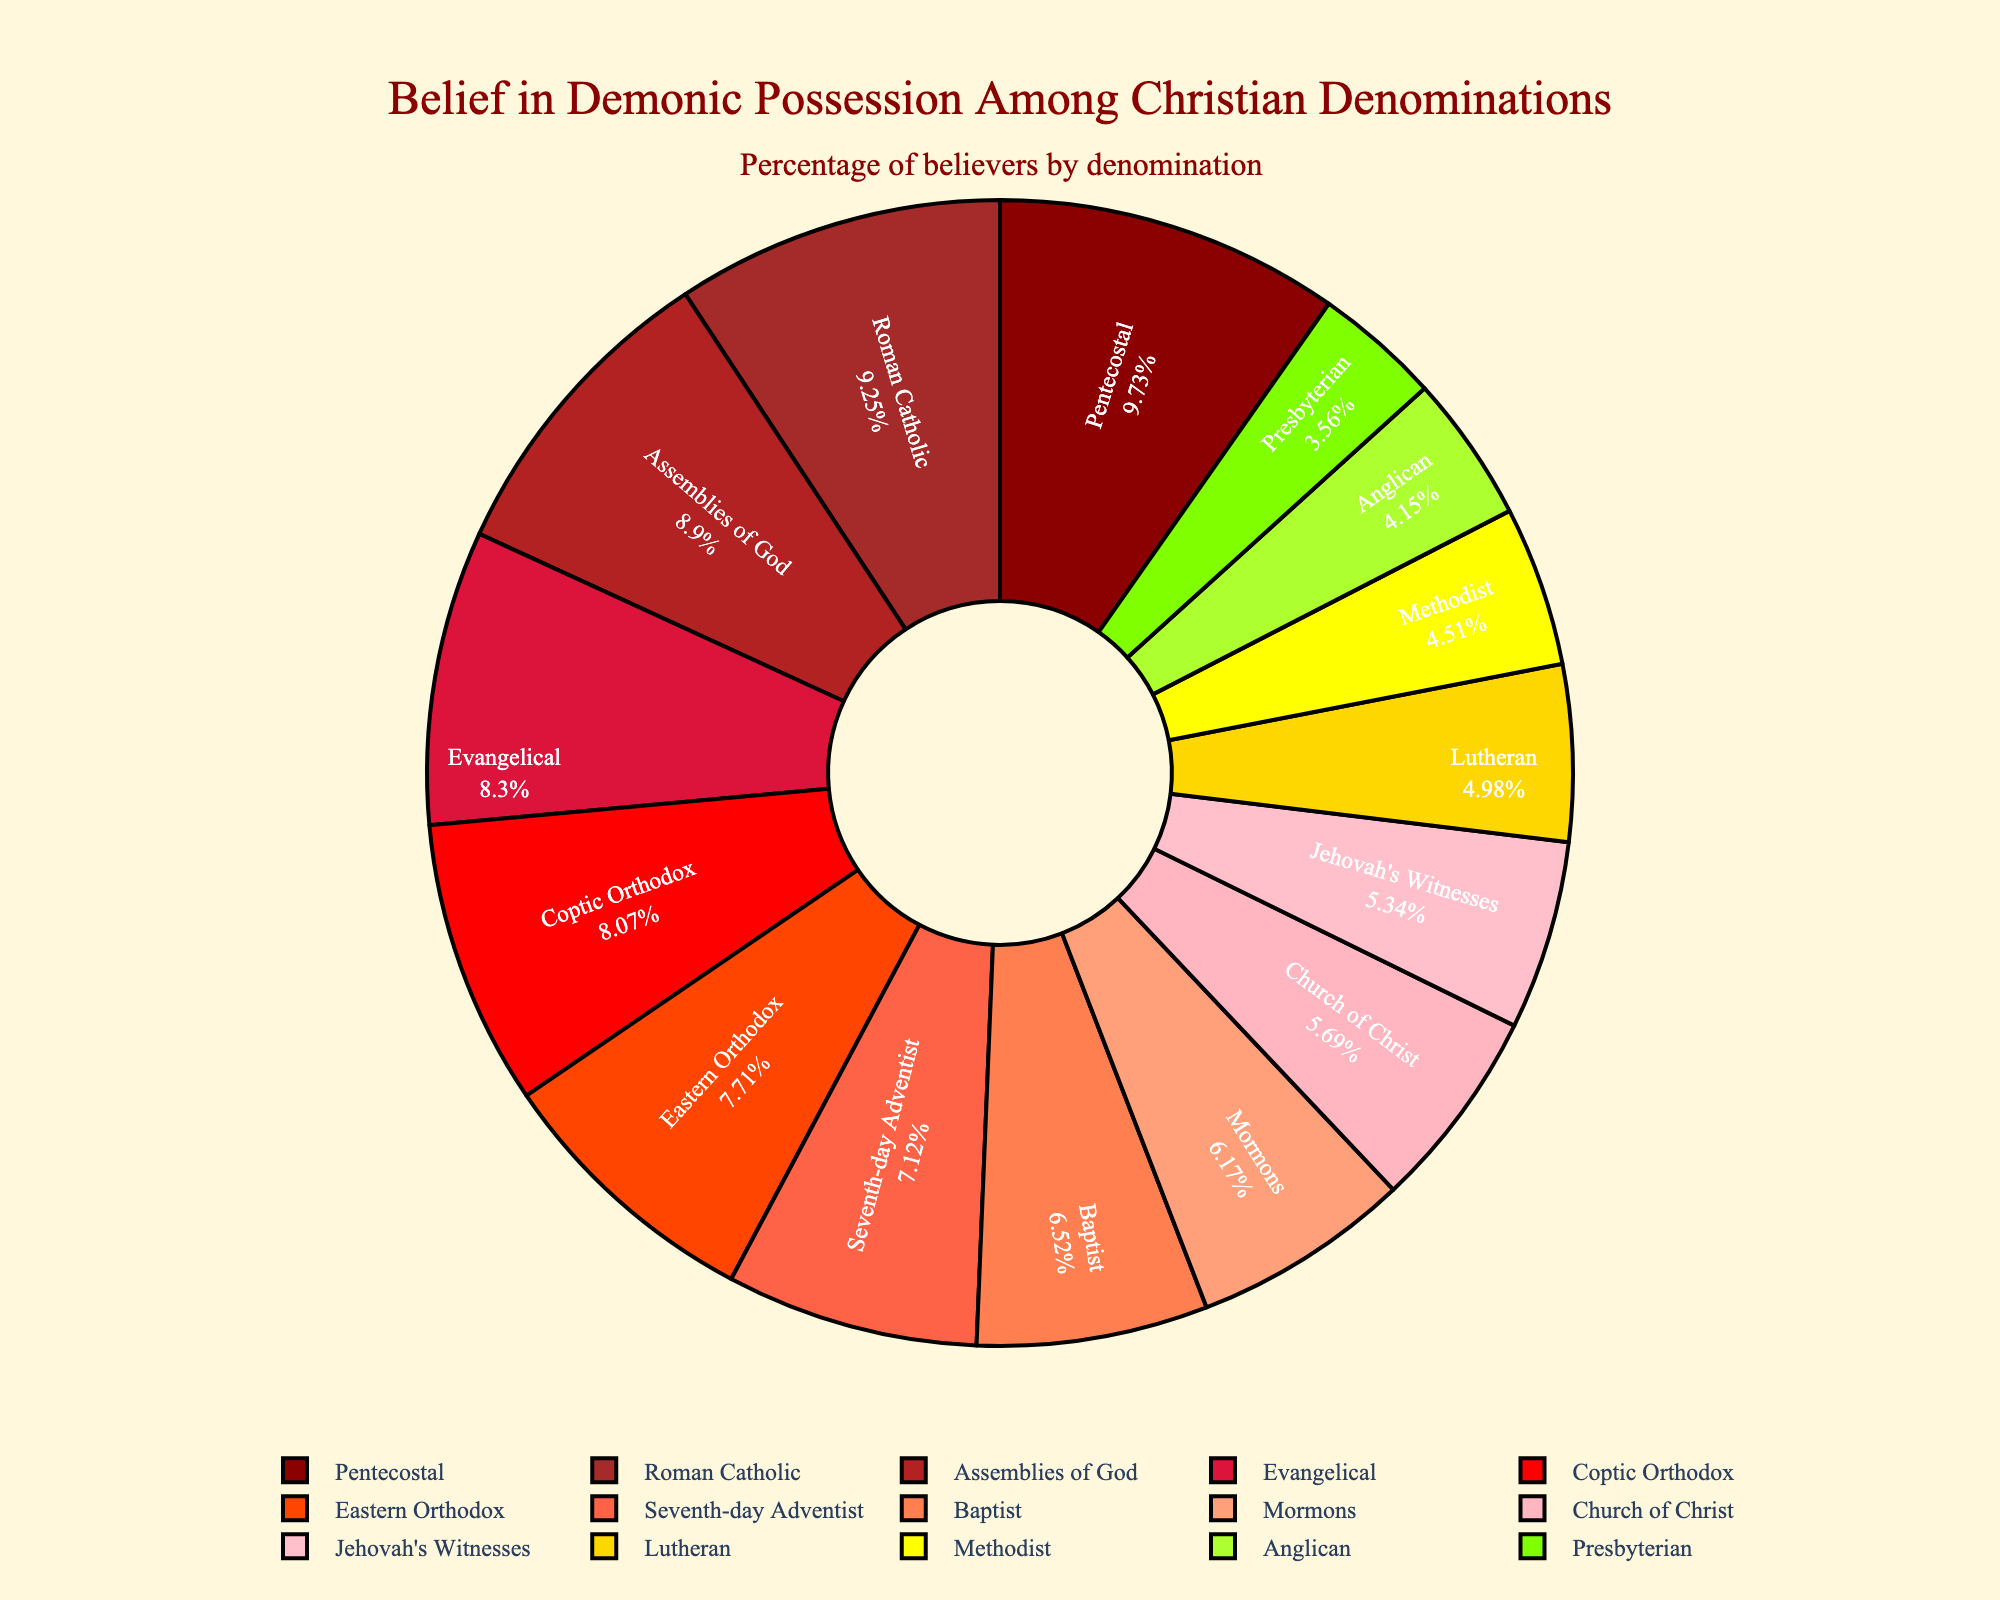Which denomination has the highest percentage belief in demonic possession? By examining the figure, the Pentecostal denomination has the largest segment, indicating the highest percentage belief at 82%.
Answer: Pentecostal Which denomination has the lowest percentage belief in demonic possession? The smallest segment of the pie chart corresponds to the Presbyterian denomination, with a percentage belief of 30%.
Answer: Presbyterian What is the difference in percentage belief between the Catholic and Anglican denominations? By referring to the figure, Roman Catholics have a belief percentage of 78%, and Anglicans have 35%. The difference is calculated as 78% - 35% = 43%.
Answer: 43% What is the combined percentage belief among the Assemblies of God and Baptist denominations? According to the figure, the Assemblies of God denomination has a 75% belief rate, while the Baptist denomination has 55%. Adding these together gives 75% + 55% = 130%.
Answer: 130% How does the belief in demonic possession in the Eastern Orthodox Church compare to that in the Jehovah's Witnesses? The figure shows Eastern Orthodox Christians at 65% and Jehovah's Witnesses at 45%. Eastern Orthodox are thus 20 percentage points higher in belief.
Answer: Eastern Orthodox are 20% higher Which denomination represented by a red segment has a belief percentage above 70%? The red segments represent high belief percentages. The Pentecostal (82%), Assemblies of God (75%), Roman Catholic (78%), and Eastern Orthodox (65%) denominations are candidates. Those above 70% are Pentecostal, Assemblies of God, and Roman Catholic.
Answer: Pentecostal, Assemblies of God, Roman Catholic What is the average belief percentage of the top five denominations in belief of demonic possession? The top five denominations by belief percentage are Pentecostal (82%), Roman Catholic (78%), Assemblies of God (75%), Eastern Orthodox (65%), and Coptic Orthodox (68%). The average is (82 + 78 + 75 + 65 + 68)/5 = 73.6%.
Answer: 73.6% If you combine the believers of the Methodist and Church of Christ, what percentage do they contribute to the total belief? Methodists have 38% and Church of Christ have 48%. Their combined percentage is 38% + 48% = 86%.
Answer: 86% Among the denominations shown, how many have a belief percentage of over 50%? By examining the chart, the denominations with belief percentages over 50% are Roman Catholic, Eastern Orthodox, Pentecostal, Evangelical, Baptist, Seventh-day Adventist, Assemblies of God, Mormons, and Coptic Orthodox. Counting these denominations, there are 9.
Answer: 9 What is the median belief percentage from the data provided in the chart? To find the median, list the belief percentages in ascending order: 30, 35, 38, 42, 45, 48, 52, 55, 60, 65, 68, 70, 75, 78, 82. With 15 data points, the median is the 8th value, which is 55%.
Answer: 55% 